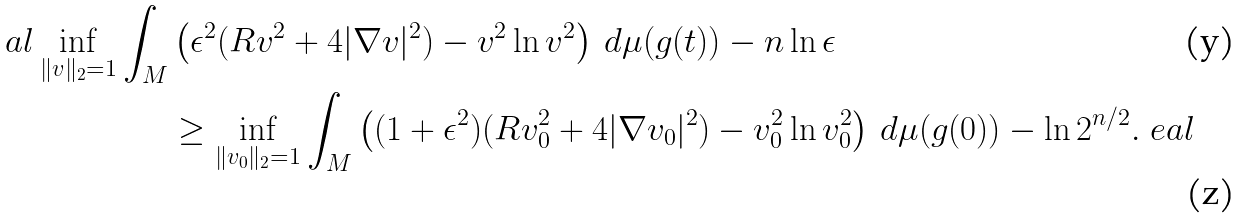<formula> <loc_0><loc_0><loc_500><loc_500>\ a l \inf _ { \| v \| _ { 2 } = 1 } \int _ { M } & \left ( \epsilon ^ { 2 } ( R v ^ { 2 } + 4 | \nabla v | ^ { 2 } ) - v ^ { 2 } \ln v ^ { 2 } \right ) \, d \mu ( g ( t ) ) - n \ln \epsilon \\ & \geq \inf _ { \| v _ { 0 } \| _ { 2 } = 1 } \int _ { M } \left ( ( 1 + \epsilon ^ { 2 } ) ( R v ^ { 2 } _ { 0 } + 4 | \nabla v _ { 0 } | ^ { 2 } ) - v ^ { 2 } _ { 0 } \ln v ^ { 2 } _ { 0 } \right ) \, d \mu ( g ( 0 ) ) - \ln 2 ^ { n / 2 } . \ e a l</formula> 